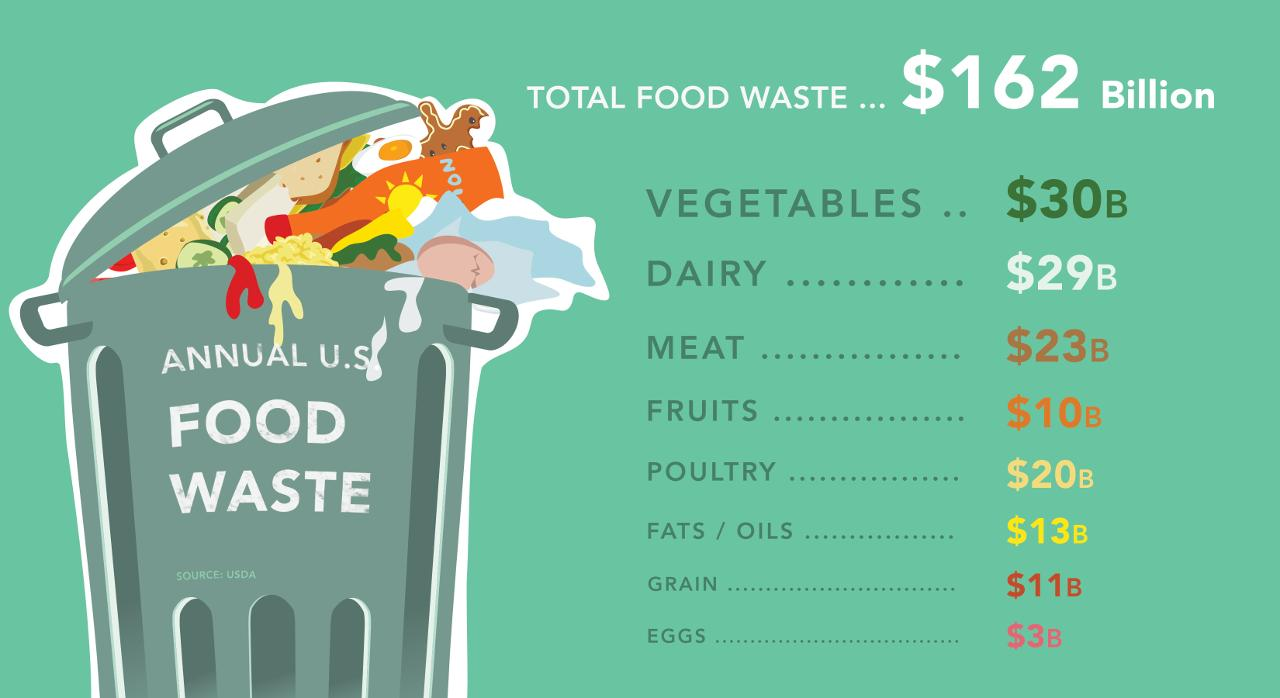Draw attention to some important aspects in this diagram. The trash can bears the inscription 'Annual U.S. Food Waste Awareness Day,' signifying the significance of this day in raising awareness about the issue of food waste in the United States. The list of food wasted shows 8 items. The total amount of food wasted in terms of dairy and eggs is approximately $32 billion. In terms of meat and poultry, the total amount of food wasted is estimated to be $43 billion. The sum of food wasted in terms of vegetables and fruits is approximately $40 billion. 